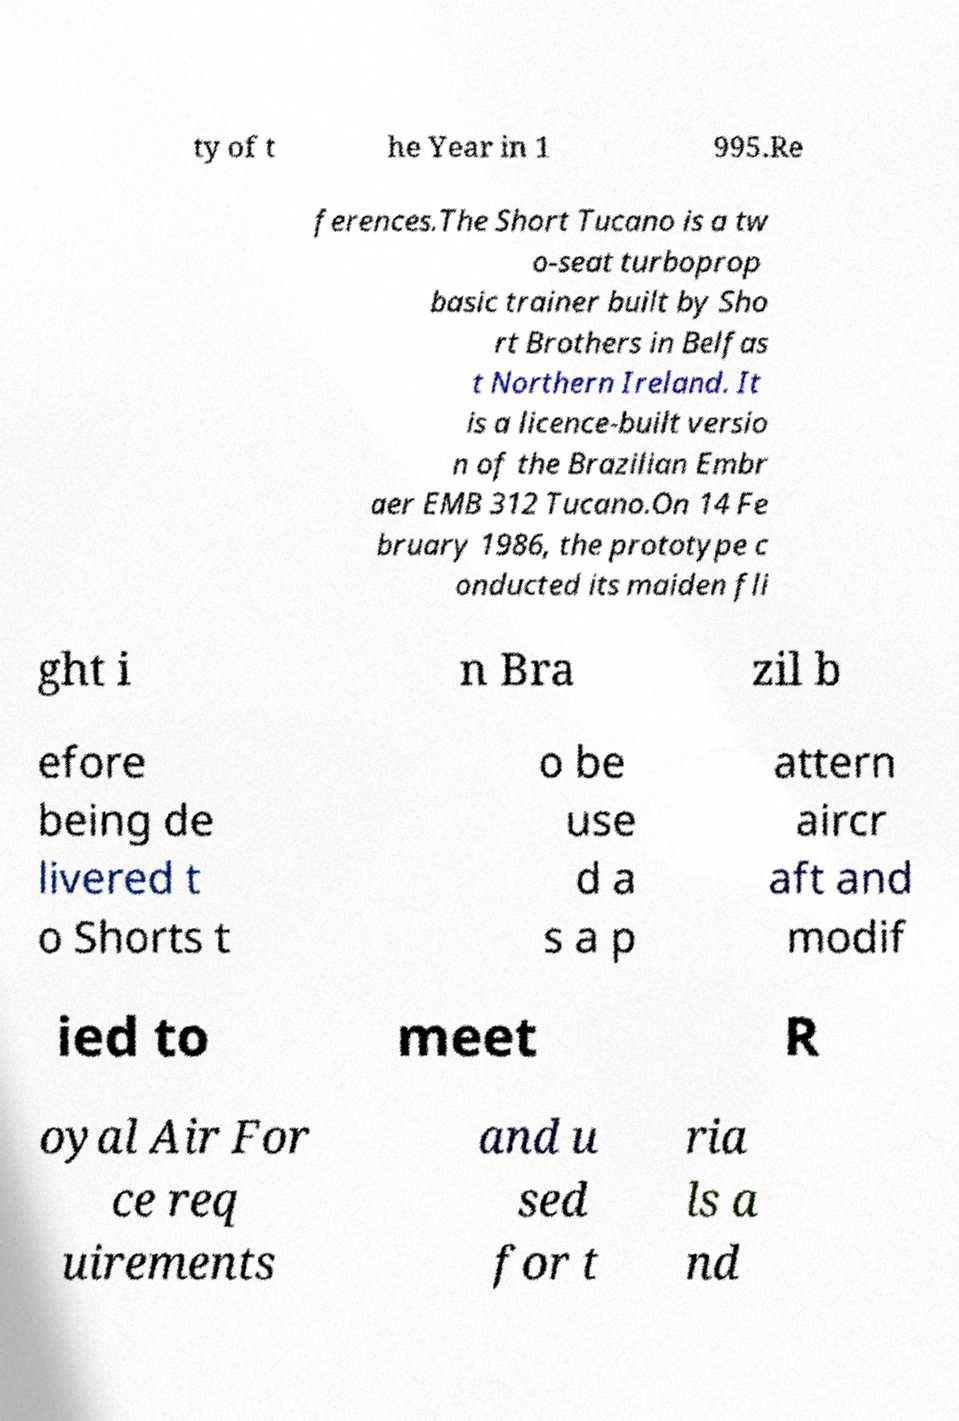Please identify and transcribe the text found in this image. ty of t he Year in 1 995.Re ferences.The Short Tucano is a tw o-seat turboprop basic trainer built by Sho rt Brothers in Belfas t Northern Ireland. It is a licence-built versio n of the Brazilian Embr aer EMB 312 Tucano.On 14 Fe bruary 1986, the prototype c onducted its maiden fli ght i n Bra zil b efore being de livered t o Shorts t o be use d a s a p attern aircr aft and modif ied to meet R oyal Air For ce req uirements and u sed for t ria ls a nd 